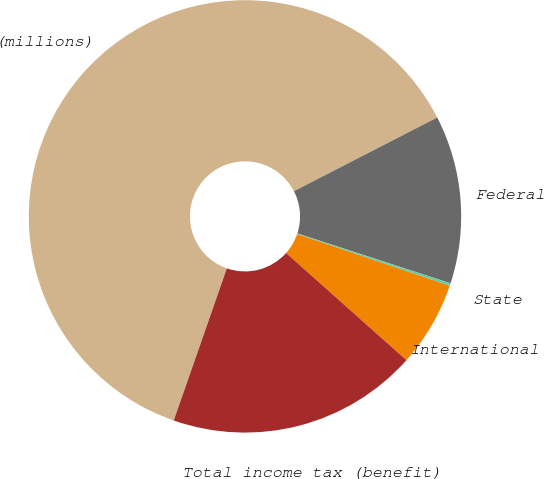Convert chart to OTSL. <chart><loc_0><loc_0><loc_500><loc_500><pie_chart><fcel>(millions)<fcel>Federal<fcel>State<fcel>International<fcel>Total income tax (benefit)<nl><fcel>62.09%<fcel>12.57%<fcel>0.19%<fcel>6.38%<fcel>18.76%<nl></chart> 